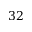Convert formula to latex. <formula><loc_0><loc_0><loc_500><loc_500>3 2</formula> 